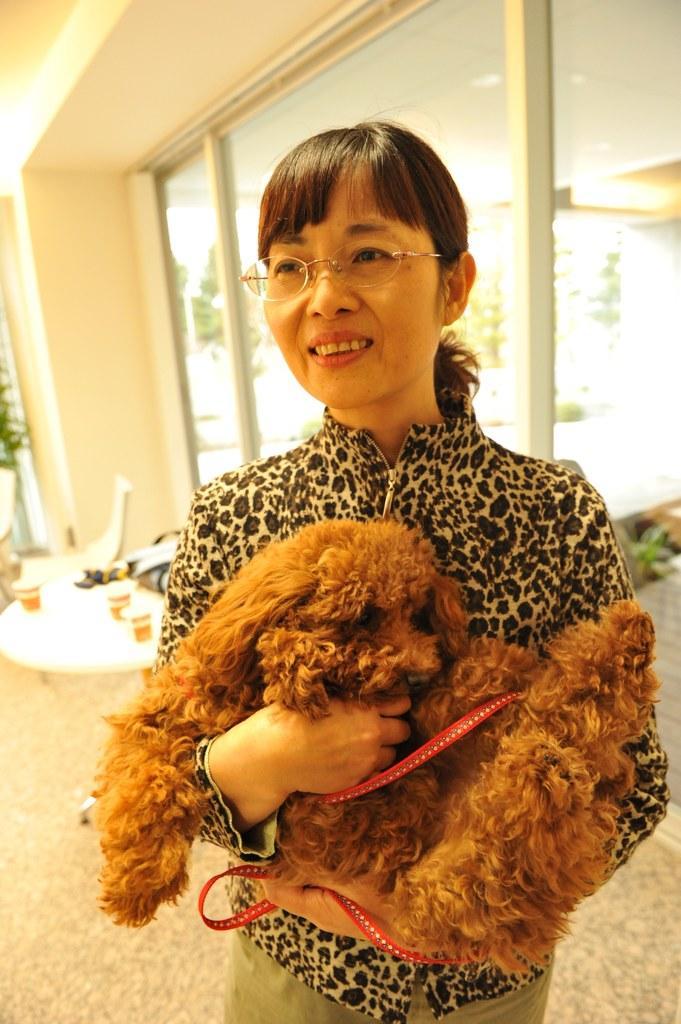Please provide a concise description of this image. Here we can see a woman holding a dog in her hand wearing spectacles and behind her we can see table and chairs present 